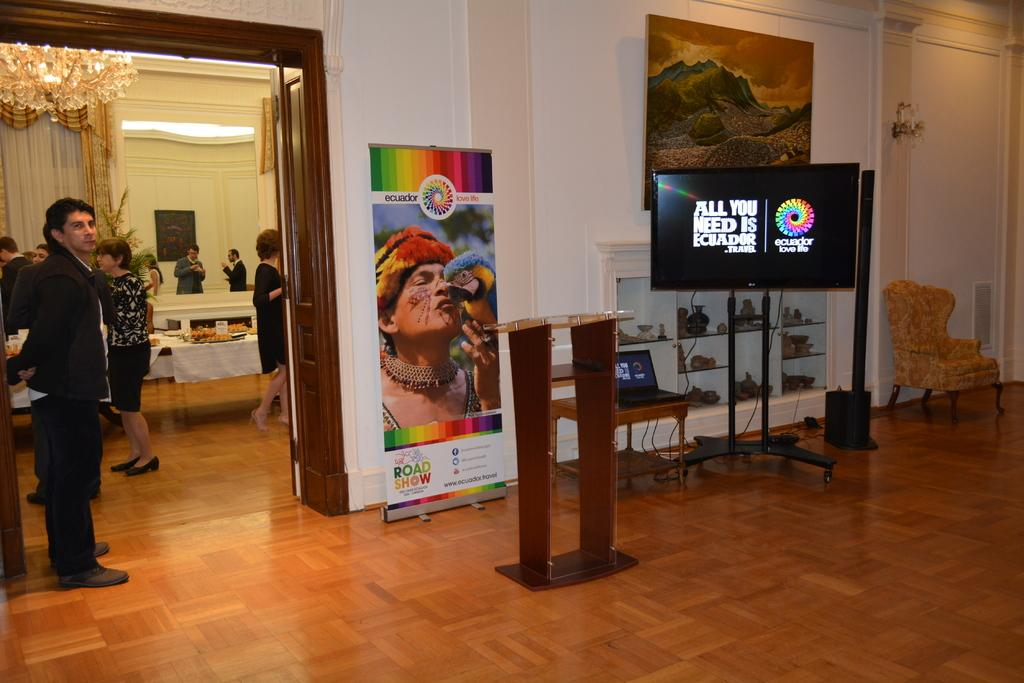Provide a one-sentence caption for the provided image. Posters and a video display tout the merits of traveling to Ecuador. 